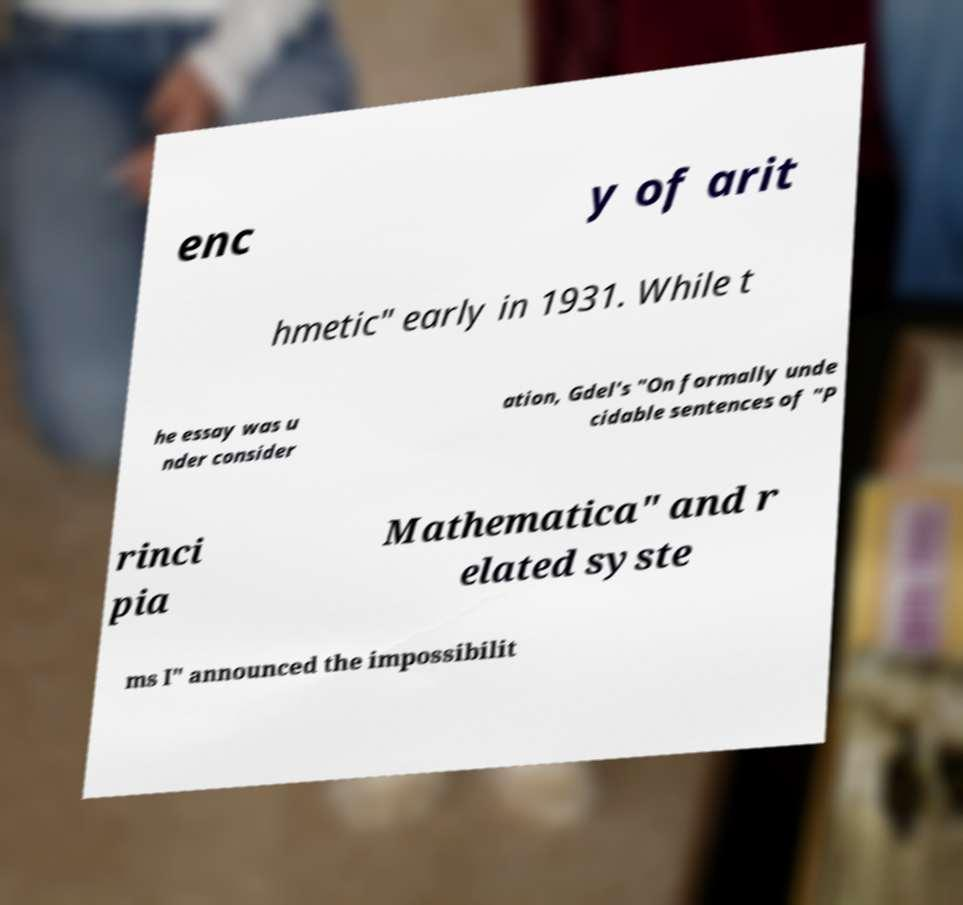Please identify and transcribe the text found in this image. enc y of arit hmetic" early in 1931. While t he essay was u nder consider ation, Gdel's "On formally unde cidable sentences of "P rinci pia Mathematica" and r elated syste ms I" announced the impossibilit 